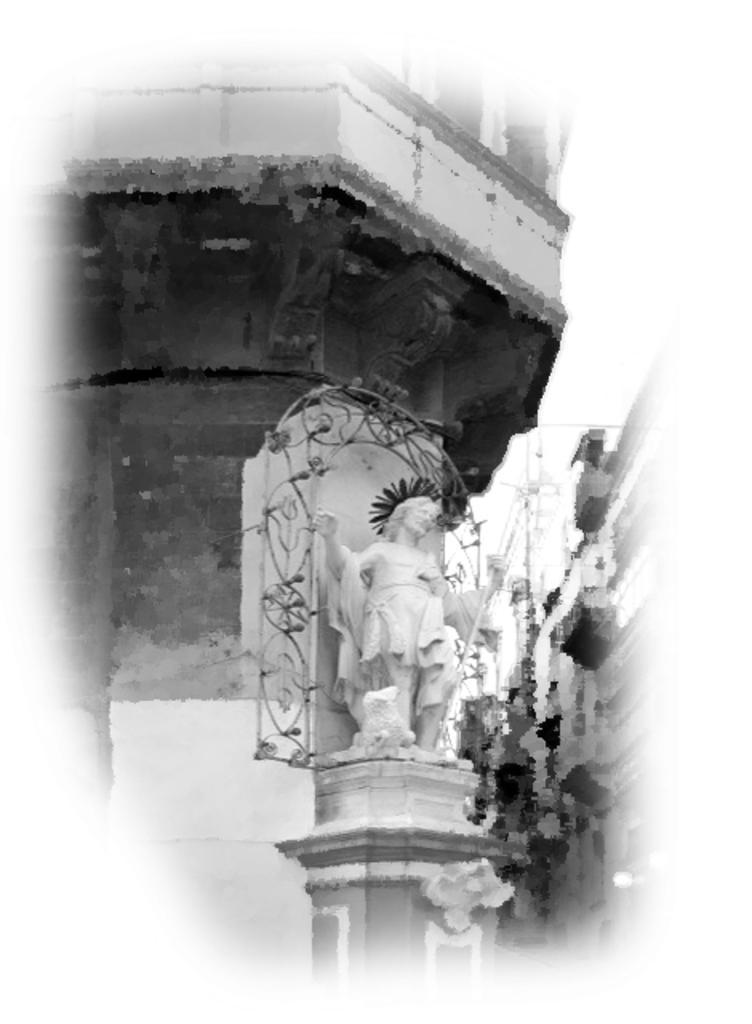In one or two sentences, can you explain what this image depicts? In this image we can see buildings, a statue in front of the building and sky in the background. 